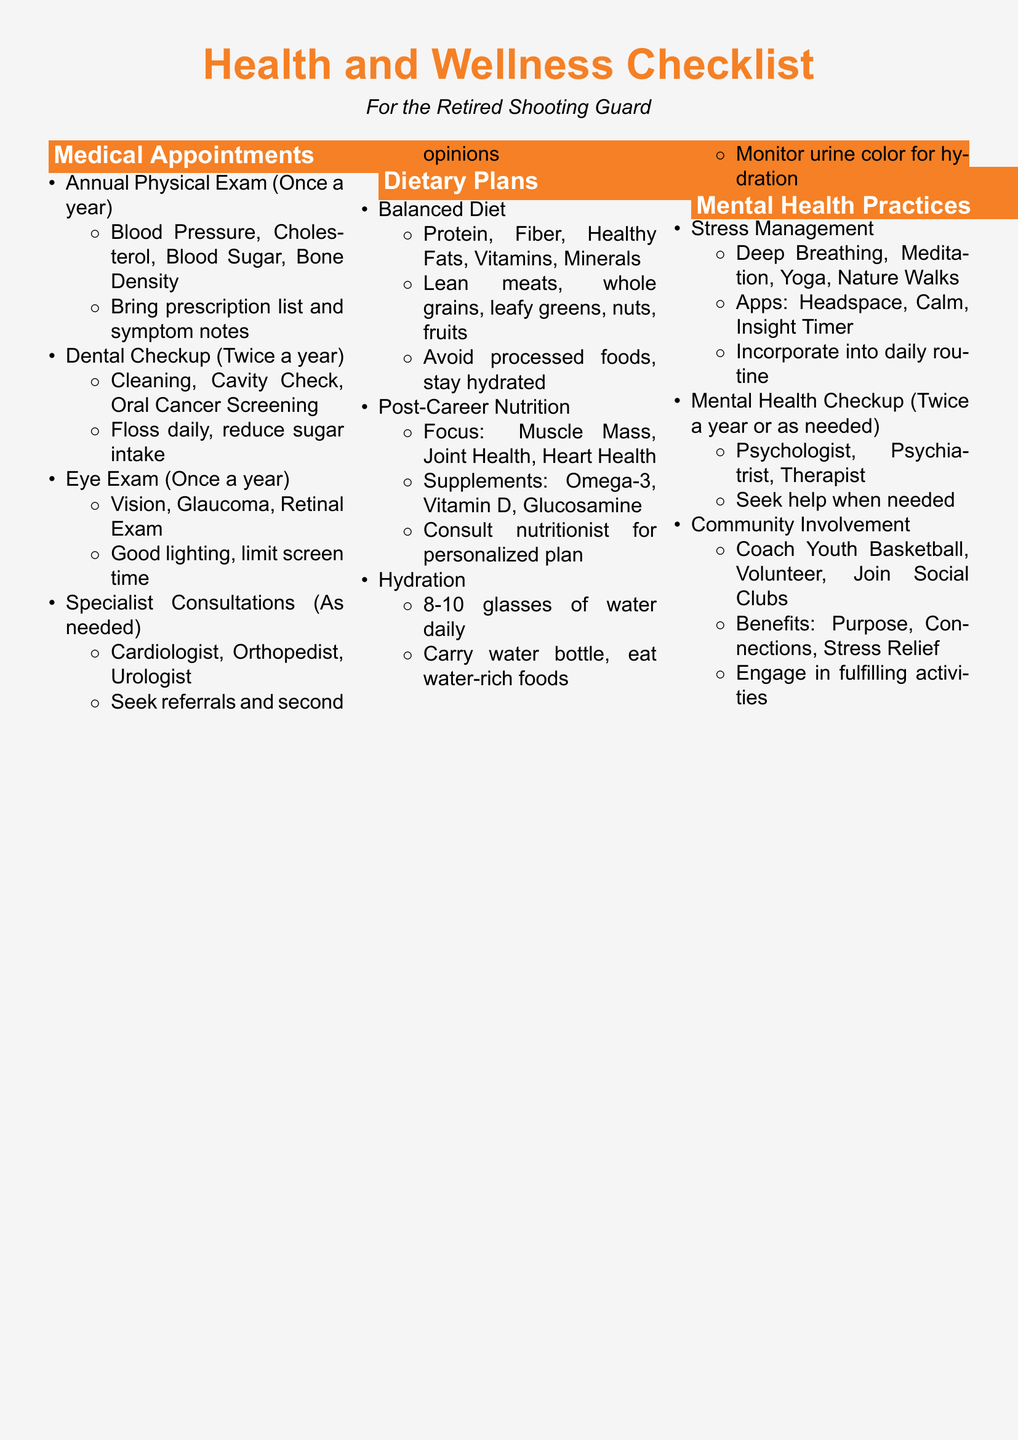What should be done during the Annual Physical Exam? The Annual Physical Exam includes checking Blood Pressure, Cholesterol, Blood Sugar, and Bone Density, along with bringing a prescription list and symptom notes.
Answer: Blood Pressure, Cholesterol, Blood Sugar, Bone Density How often should dental checkups occur? The document states that dental checkups should occur twice a year.
Answer: Twice a year What is a key dietary focus for post-career nutrition? The focus for post-career nutrition is on Muscle Mass, Joint Health, and Heart Health.
Answer: Muscle Mass, Joint Health, Heart Health What type of mental health professional should be consulted for a mental health checkup? A mental health checkup should involve a Psychologist, Psychiatrist, or Therapist.
Answer: Psychologist, Psychiatrist, Therapist How many glasses of water should be consumed daily? The recommended daily water intake mentioned in the document is 8-10 glasses.
Answer: 8-10 glasses What are two activities recommended for stress management? The document suggests Deep Breathing and Meditation as two activities for stress management.
Answer: Deep Breathing, Meditation What should be avoided in a balanced diet? The checklist advises avoiding processed foods as part of maintaining a balanced diet.
Answer: Processed foods How can one monitor hydration levels? The document states that hydration can be monitored by checking urine color.
Answer: Monitor urine color What benefit does community involvement provide? Community involvement offers benefits such as Purpose, Connections, and Stress Relief.
Answer: Purpose, Connections, Stress Relief 